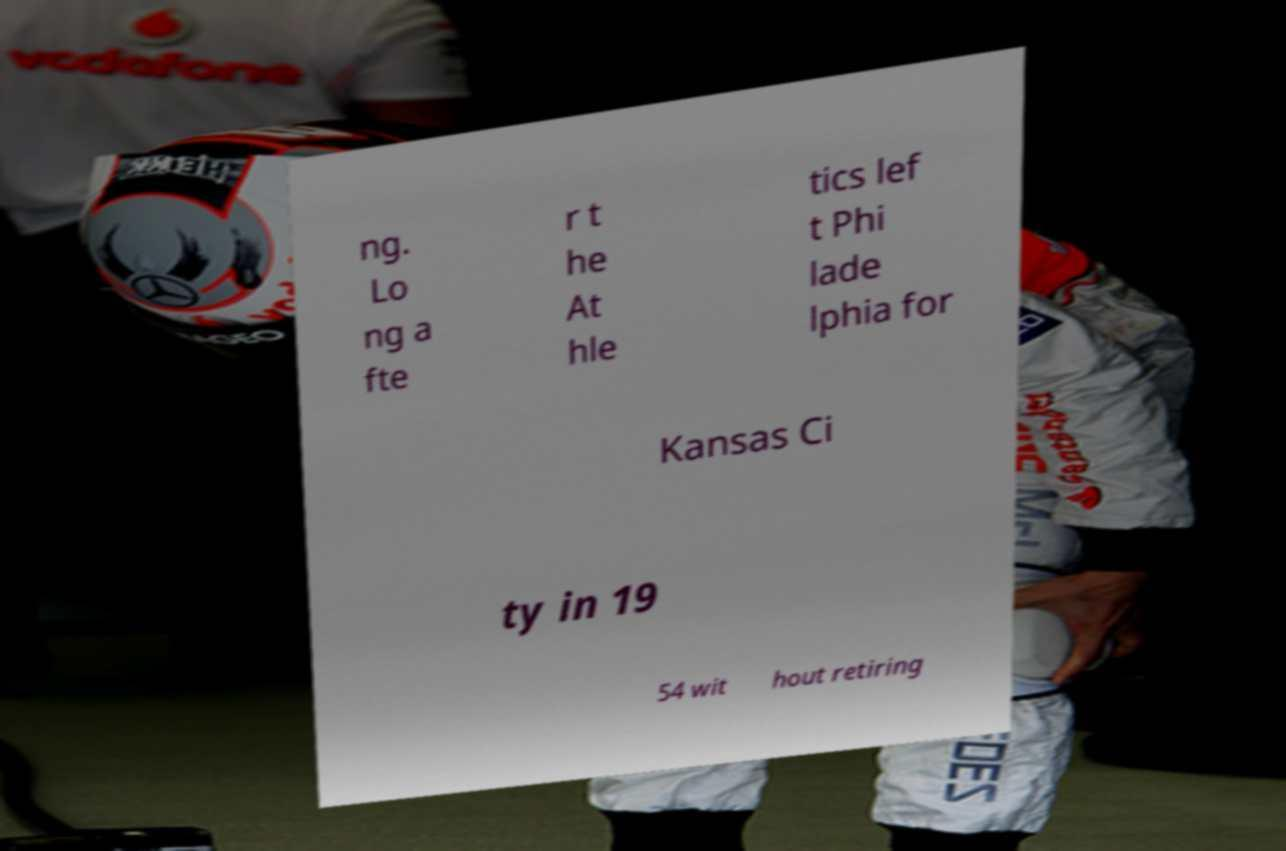Could you assist in decoding the text presented in this image and type it out clearly? ng. Lo ng a fte r t he At hle tics lef t Phi lade lphia for Kansas Ci ty in 19 54 wit hout retiring 